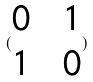Convert formula to latex. <formula><loc_0><loc_0><loc_500><loc_500>( \begin{matrix} 0 & & 1 \\ 1 & & 0 \end{matrix} )</formula> 